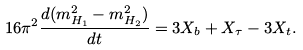Convert formula to latex. <formula><loc_0><loc_0><loc_500><loc_500>1 6 \pi ^ { 2 } \frac { d ( m _ { H _ { 1 } } ^ { 2 } - m _ { H _ { 2 } } ^ { 2 } ) } { d t } = 3 X _ { b } + X _ { \tau } - 3 X _ { t } .</formula> 